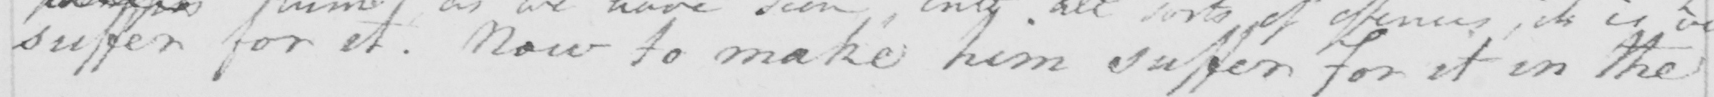Can you read and transcribe this handwriting? suffer for it . Now to make him suffer for it in the 